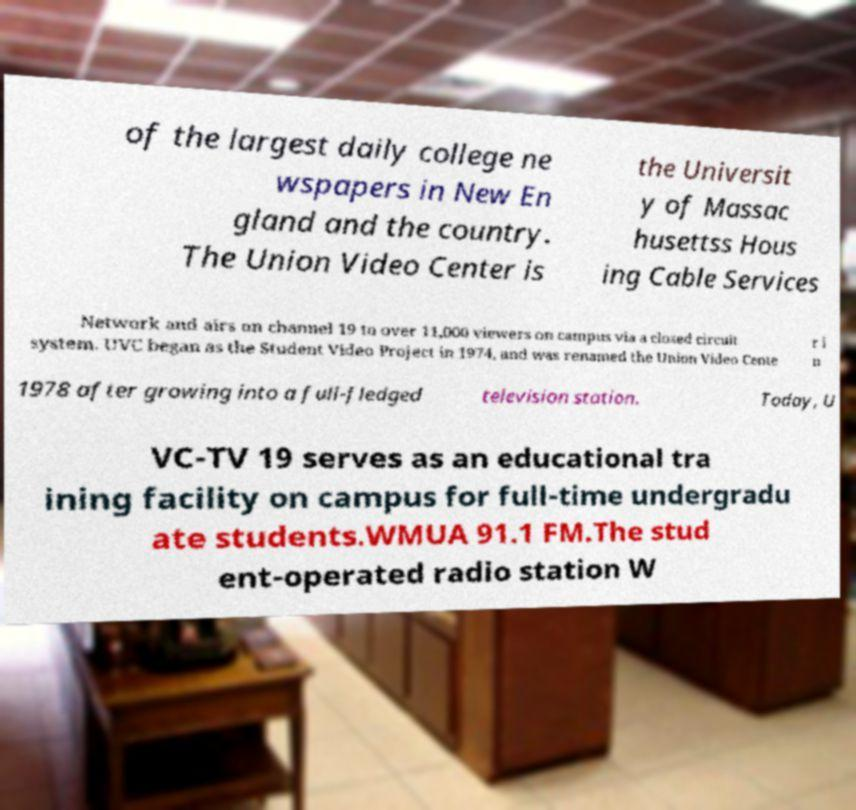Can you accurately transcribe the text from the provided image for me? of the largest daily college ne wspapers in New En gland and the country. The Union Video Center is the Universit y of Massac husettss Hous ing Cable Services Network and airs on channel 19 to over 11,000 viewers on campus via a closed circuit system. UVC began as the Student Video Project in 1974, and was renamed the Union Video Cente r i n 1978 after growing into a full-fledged television station. Today, U VC-TV 19 serves as an educational tra ining facility on campus for full-time undergradu ate students.WMUA 91.1 FM.The stud ent-operated radio station W 